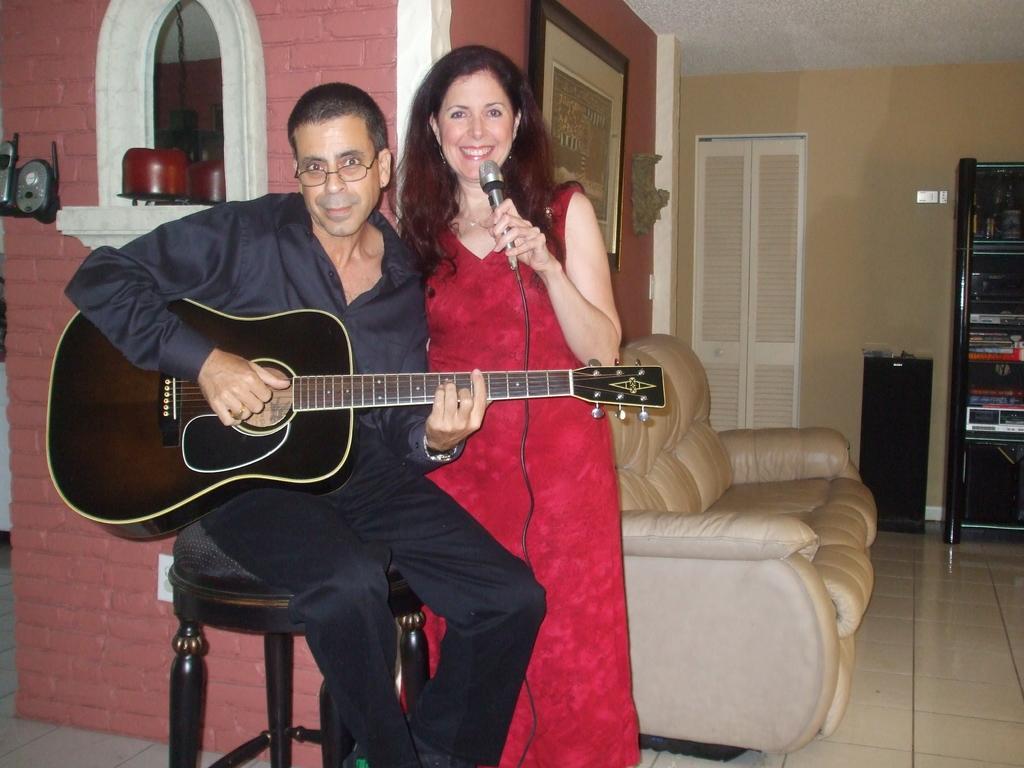Could you give a brief overview of what you see in this image? In this picture there is a man and woman, the man is sitting and playing the guitar and woman is holding a microphone in her left hand and smiling behind them there is a wall, there is a couch on the right and a door 